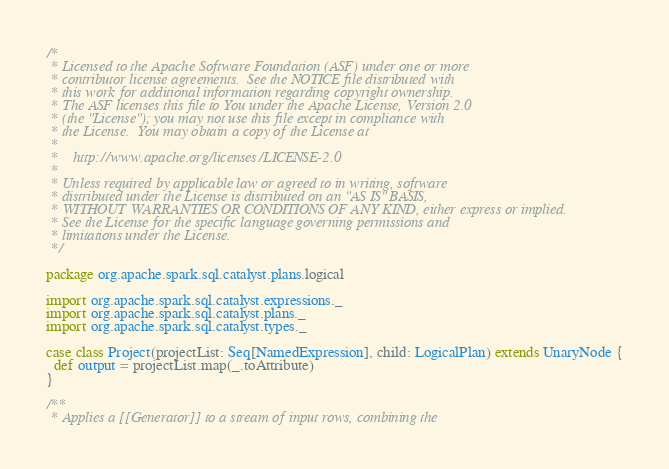<code> <loc_0><loc_0><loc_500><loc_500><_Scala_>/*
 * Licensed to the Apache Software Foundation (ASF) under one or more
 * contributor license agreements.  See the NOTICE file distributed with
 * this work for additional information regarding copyright ownership.
 * The ASF licenses this file to You under the Apache License, Version 2.0
 * (the "License"); you may not use this file except in compliance with
 * the License.  You may obtain a copy of the License at
 *
 *    http://www.apache.org/licenses/LICENSE-2.0
 *
 * Unless required by applicable law or agreed to in writing, software
 * distributed under the License is distributed on an "AS IS" BASIS,
 * WITHOUT WARRANTIES OR CONDITIONS OF ANY KIND, either express or implied.
 * See the License for the specific language governing permissions and
 * limitations under the License.
 */

package org.apache.spark.sql.catalyst.plans.logical

import org.apache.spark.sql.catalyst.expressions._
import org.apache.spark.sql.catalyst.plans._
import org.apache.spark.sql.catalyst.types._

case class Project(projectList: Seq[NamedExpression], child: LogicalPlan) extends UnaryNode {
  def output = projectList.map(_.toAttribute)
}

/**
 * Applies a [[Generator]] to a stream of input rows, combining the</code> 